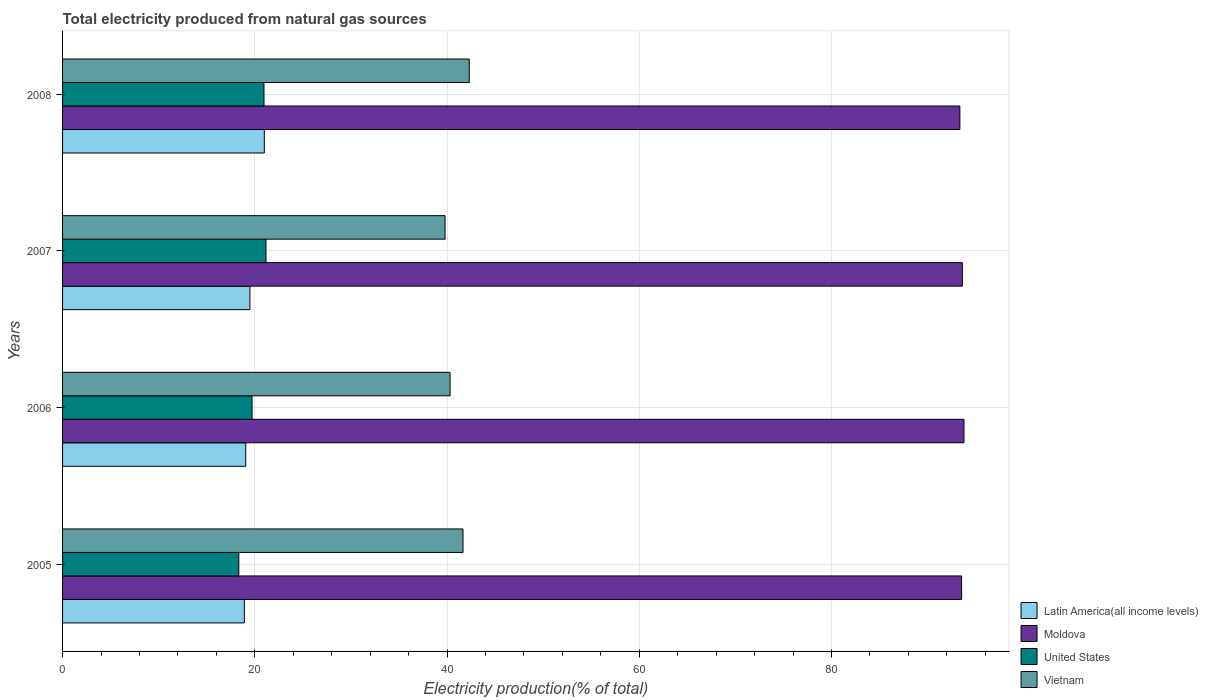How many different coloured bars are there?
Your answer should be compact. 4. Are the number of bars per tick equal to the number of legend labels?
Ensure brevity in your answer.  Yes. Are the number of bars on each tick of the Y-axis equal?
Make the answer very short. Yes. How many bars are there on the 2nd tick from the top?
Ensure brevity in your answer.  4. In how many cases, is the number of bars for a given year not equal to the number of legend labels?
Keep it short and to the point. 0. What is the total electricity produced in Vietnam in 2008?
Provide a short and direct response. 42.31. Across all years, what is the maximum total electricity produced in Moldova?
Provide a short and direct response. 93.78. Across all years, what is the minimum total electricity produced in Vietnam?
Ensure brevity in your answer.  39.8. In which year was the total electricity produced in Vietnam maximum?
Provide a short and direct response. 2008. In which year was the total electricity produced in Vietnam minimum?
Provide a succinct answer. 2007. What is the total total electricity produced in Latin America(all income levels) in the graph?
Make the answer very short. 78.46. What is the difference between the total electricity produced in Latin America(all income levels) in 2005 and that in 2006?
Your response must be concise. -0.14. What is the difference between the total electricity produced in Latin America(all income levels) in 2005 and the total electricity produced in Moldova in 2007?
Your answer should be compact. -74.7. What is the average total electricity produced in Moldova per year?
Offer a terse response. 93.57. In the year 2007, what is the difference between the total electricity produced in Moldova and total electricity produced in United States?
Provide a short and direct response. 72.45. What is the ratio of the total electricity produced in Vietnam in 2005 to that in 2006?
Your response must be concise. 1.03. Is the difference between the total electricity produced in Moldova in 2006 and 2008 greater than the difference between the total electricity produced in United States in 2006 and 2008?
Offer a terse response. Yes. What is the difference between the highest and the second highest total electricity produced in Moldova?
Keep it short and to the point. 0.17. What is the difference between the highest and the lowest total electricity produced in Vietnam?
Keep it short and to the point. 2.52. Is the sum of the total electricity produced in Moldova in 2006 and 2008 greater than the maximum total electricity produced in United States across all years?
Offer a very short reply. Yes. What does the 4th bar from the top in 2006 represents?
Offer a terse response. Latin America(all income levels). What does the 1st bar from the bottom in 2007 represents?
Make the answer very short. Latin America(all income levels). Is it the case that in every year, the sum of the total electricity produced in Vietnam and total electricity produced in Latin America(all income levels) is greater than the total electricity produced in United States?
Offer a very short reply. Yes. How many bars are there?
Your answer should be compact. 16. Are all the bars in the graph horizontal?
Your response must be concise. Yes. How many years are there in the graph?
Keep it short and to the point. 4. Are the values on the major ticks of X-axis written in scientific E-notation?
Make the answer very short. No. Does the graph contain grids?
Your answer should be compact. Yes. How many legend labels are there?
Offer a terse response. 4. How are the legend labels stacked?
Your answer should be very brief. Vertical. What is the title of the graph?
Your answer should be compact. Total electricity produced from natural gas sources. What is the Electricity production(% of total) of Latin America(all income levels) in 2005?
Give a very brief answer. 18.91. What is the Electricity production(% of total) of Moldova in 2005?
Your response must be concise. 93.54. What is the Electricity production(% of total) of United States in 2005?
Ensure brevity in your answer.  18.34. What is the Electricity production(% of total) in Vietnam in 2005?
Give a very brief answer. 41.66. What is the Electricity production(% of total) in Latin America(all income levels) in 2006?
Provide a short and direct response. 19.06. What is the Electricity production(% of total) in Moldova in 2006?
Offer a very short reply. 93.78. What is the Electricity production(% of total) of United States in 2006?
Offer a very short reply. 19.71. What is the Electricity production(% of total) of Vietnam in 2006?
Offer a very short reply. 40.32. What is the Electricity production(% of total) of Latin America(all income levels) in 2007?
Keep it short and to the point. 19.49. What is the Electricity production(% of total) in Moldova in 2007?
Offer a terse response. 93.62. What is the Electricity production(% of total) of United States in 2007?
Provide a short and direct response. 21.17. What is the Electricity production(% of total) in Vietnam in 2007?
Ensure brevity in your answer.  39.8. What is the Electricity production(% of total) of Latin America(all income levels) in 2008?
Your response must be concise. 20.99. What is the Electricity production(% of total) of Moldova in 2008?
Provide a succinct answer. 93.36. What is the Electricity production(% of total) in United States in 2008?
Give a very brief answer. 20.96. What is the Electricity production(% of total) in Vietnam in 2008?
Make the answer very short. 42.31. Across all years, what is the maximum Electricity production(% of total) in Latin America(all income levels)?
Offer a very short reply. 20.99. Across all years, what is the maximum Electricity production(% of total) in Moldova?
Your response must be concise. 93.78. Across all years, what is the maximum Electricity production(% of total) of United States?
Give a very brief answer. 21.17. Across all years, what is the maximum Electricity production(% of total) of Vietnam?
Your response must be concise. 42.31. Across all years, what is the minimum Electricity production(% of total) of Latin America(all income levels)?
Provide a short and direct response. 18.91. Across all years, what is the minimum Electricity production(% of total) in Moldova?
Provide a succinct answer. 93.36. Across all years, what is the minimum Electricity production(% of total) in United States?
Your response must be concise. 18.34. Across all years, what is the minimum Electricity production(% of total) in Vietnam?
Your answer should be very brief. 39.8. What is the total Electricity production(% of total) in Latin America(all income levels) in the graph?
Offer a very short reply. 78.46. What is the total Electricity production(% of total) in Moldova in the graph?
Keep it short and to the point. 374.3. What is the total Electricity production(% of total) of United States in the graph?
Offer a terse response. 80.18. What is the total Electricity production(% of total) of Vietnam in the graph?
Offer a very short reply. 164.09. What is the difference between the Electricity production(% of total) of Latin America(all income levels) in 2005 and that in 2006?
Keep it short and to the point. -0.14. What is the difference between the Electricity production(% of total) in Moldova in 2005 and that in 2006?
Keep it short and to the point. -0.24. What is the difference between the Electricity production(% of total) of United States in 2005 and that in 2006?
Offer a very short reply. -1.38. What is the difference between the Electricity production(% of total) in Vietnam in 2005 and that in 2006?
Your answer should be very brief. 1.34. What is the difference between the Electricity production(% of total) in Latin America(all income levels) in 2005 and that in 2007?
Keep it short and to the point. -0.58. What is the difference between the Electricity production(% of total) in Moldova in 2005 and that in 2007?
Your answer should be compact. -0.08. What is the difference between the Electricity production(% of total) in United States in 2005 and that in 2007?
Your response must be concise. -2.83. What is the difference between the Electricity production(% of total) of Vietnam in 2005 and that in 2007?
Offer a very short reply. 1.87. What is the difference between the Electricity production(% of total) in Latin America(all income levels) in 2005 and that in 2008?
Offer a terse response. -2.08. What is the difference between the Electricity production(% of total) in Moldova in 2005 and that in 2008?
Your answer should be very brief. 0.18. What is the difference between the Electricity production(% of total) in United States in 2005 and that in 2008?
Provide a succinct answer. -2.62. What is the difference between the Electricity production(% of total) in Vietnam in 2005 and that in 2008?
Your answer should be compact. -0.65. What is the difference between the Electricity production(% of total) in Latin America(all income levels) in 2006 and that in 2007?
Offer a very short reply. -0.43. What is the difference between the Electricity production(% of total) of Moldova in 2006 and that in 2007?
Offer a very short reply. 0.17. What is the difference between the Electricity production(% of total) in United States in 2006 and that in 2007?
Offer a terse response. -1.45. What is the difference between the Electricity production(% of total) in Vietnam in 2006 and that in 2007?
Offer a very short reply. 0.52. What is the difference between the Electricity production(% of total) in Latin America(all income levels) in 2006 and that in 2008?
Provide a succinct answer. -1.93. What is the difference between the Electricity production(% of total) of Moldova in 2006 and that in 2008?
Keep it short and to the point. 0.43. What is the difference between the Electricity production(% of total) in United States in 2006 and that in 2008?
Give a very brief answer. -1.24. What is the difference between the Electricity production(% of total) in Vietnam in 2006 and that in 2008?
Make the answer very short. -2. What is the difference between the Electricity production(% of total) in Latin America(all income levels) in 2007 and that in 2008?
Your answer should be very brief. -1.5. What is the difference between the Electricity production(% of total) of Moldova in 2007 and that in 2008?
Your answer should be very brief. 0.26. What is the difference between the Electricity production(% of total) of United States in 2007 and that in 2008?
Your answer should be very brief. 0.21. What is the difference between the Electricity production(% of total) of Vietnam in 2007 and that in 2008?
Keep it short and to the point. -2.52. What is the difference between the Electricity production(% of total) in Latin America(all income levels) in 2005 and the Electricity production(% of total) in Moldova in 2006?
Your answer should be very brief. -74.87. What is the difference between the Electricity production(% of total) of Latin America(all income levels) in 2005 and the Electricity production(% of total) of United States in 2006?
Offer a terse response. -0.8. What is the difference between the Electricity production(% of total) of Latin America(all income levels) in 2005 and the Electricity production(% of total) of Vietnam in 2006?
Your response must be concise. -21.4. What is the difference between the Electricity production(% of total) of Moldova in 2005 and the Electricity production(% of total) of United States in 2006?
Provide a succinct answer. 73.83. What is the difference between the Electricity production(% of total) in Moldova in 2005 and the Electricity production(% of total) in Vietnam in 2006?
Your answer should be very brief. 53.22. What is the difference between the Electricity production(% of total) in United States in 2005 and the Electricity production(% of total) in Vietnam in 2006?
Keep it short and to the point. -21.98. What is the difference between the Electricity production(% of total) in Latin America(all income levels) in 2005 and the Electricity production(% of total) in Moldova in 2007?
Make the answer very short. -74.7. What is the difference between the Electricity production(% of total) of Latin America(all income levels) in 2005 and the Electricity production(% of total) of United States in 2007?
Offer a very short reply. -2.25. What is the difference between the Electricity production(% of total) of Latin America(all income levels) in 2005 and the Electricity production(% of total) of Vietnam in 2007?
Make the answer very short. -20.88. What is the difference between the Electricity production(% of total) in Moldova in 2005 and the Electricity production(% of total) in United States in 2007?
Give a very brief answer. 72.37. What is the difference between the Electricity production(% of total) of Moldova in 2005 and the Electricity production(% of total) of Vietnam in 2007?
Make the answer very short. 53.74. What is the difference between the Electricity production(% of total) in United States in 2005 and the Electricity production(% of total) in Vietnam in 2007?
Your answer should be compact. -21.46. What is the difference between the Electricity production(% of total) in Latin America(all income levels) in 2005 and the Electricity production(% of total) in Moldova in 2008?
Give a very brief answer. -74.44. What is the difference between the Electricity production(% of total) in Latin America(all income levels) in 2005 and the Electricity production(% of total) in United States in 2008?
Provide a succinct answer. -2.04. What is the difference between the Electricity production(% of total) of Latin America(all income levels) in 2005 and the Electricity production(% of total) of Vietnam in 2008?
Your answer should be compact. -23.4. What is the difference between the Electricity production(% of total) in Moldova in 2005 and the Electricity production(% of total) in United States in 2008?
Your answer should be compact. 72.58. What is the difference between the Electricity production(% of total) of Moldova in 2005 and the Electricity production(% of total) of Vietnam in 2008?
Your answer should be very brief. 51.23. What is the difference between the Electricity production(% of total) in United States in 2005 and the Electricity production(% of total) in Vietnam in 2008?
Provide a succinct answer. -23.97. What is the difference between the Electricity production(% of total) in Latin America(all income levels) in 2006 and the Electricity production(% of total) in Moldova in 2007?
Your response must be concise. -74.56. What is the difference between the Electricity production(% of total) in Latin America(all income levels) in 2006 and the Electricity production(% of total) in United States in 2007?
Make the answer very short. -2.11. What is the difference between the Electricity production(% of total) in Latin America(all income levels) in 2006 and the Electricity production(% of total) in Vietnam in 2007?
Provide a short and direct response. -20.74. What is the difference between the Electricity production(% of total) in Moldova in 2006 and the Electricity production(% of total) in United States in 2007?
Offer a very short reply. 72.62. What is the difference between the Electricity production(% of total) in Moldova in 2006 and the Electricity production(% of total) in Vietnam in 2007?
Give a very brief answer. 53.99. What is the difference between the Electricity production(% of total) of United States in 2006 and the Electricity production(% of total) of Vietnam in 2007?
Ensure brevity in your answer.  -20.08. What is the difference between the Electricity production(% of total) of Latin America(all income levels) in 2006 and the Electricity production(% of total) of Moldova in 2008?
Keep it short and to the point. -74.3. What is the difference between the Electricity production(% of total) of Latin America(all income levels) in 2006 and the Electricity production(% of total) of United States in 2008?
Ensure brevity in your answer.  -1.9. What is the difference between the Electricity production(% of total) in Latin America(all income levels) in 2006 and the Electricity production(% of total) in Vietnam in 2008?
Give a very brief answer. -23.25. What is the difference between the Electricity production(% of total) of Moldova in 2006 and the Electricity production(% of total) of United States in 2008?
Your response must be concise. 72.83. What is the difference between the Electricity production(% of total) in Moldova in 2006 and the Electricity production(% of total) in Vietnam in 2008?
Provide a succinct answer. 51.47. What is the difference between the Electricity production(% of total) of United States in 2006 and the Electricity production(% of total) of Vietnam in 2008?
Make the answer very short. -22.6. What is the difference between the Electricity production(% of total) in Latin America(all income levels) in 2007 and the Electricity production(% of total) in Moldova in 2008?
Provide a succinct answer. -73.86. What is the difference between the Electricity production(% of total) of Latin America(all income levels) in 2007 and the Electricity production(% of total) of United States in 2008?
Give a very brief answer. -1.46. What is the difference between the Electricity production(% of total) of Latin America(all income levels) in 2007 and the Electricity production(% of total) of Vietnam in 2008?
Give a very brief answer. -22.82. What is the difference between the Electricity production(% of total) in Moldova in 2007 and the Electricity production(% of total) in United States in 2008?
Make the answer very short. 72.66. What is the difference between the Electricity production(% of total) of Moldova in 2007 and the Electricity production(% of total) of Vietnam in 2008?
Your answer should be very brief. 51.3. What is the difference between the Electricity production(% of total) in United States in 2007 and the Electricity production(% of total) in Vietnam in 2008?
Offer a terse response. -21.15. What is the average Electricity production(% of total) in Latin America(all income levels) per year?
Your answer should be very brief. 19.61. What is the average Electricity production(% of total) of Moldova per year?
Keep it short and to the point. 93.57. What is the average Electricity production(% of total) in United States per year?
Keep it short and to the point. 20.04. What is the average Electricity production(% of total) of Vietnam per year?
Ensure brevity in your answer.  41.02. In the year 2005, what is the difference between the Electricity production(% of total) in Latin America(all income levels) and Electricity production(% of total) in Moldova?
Offer a terse response. -74.62. In the year 2005, what is the difference between the Electricity production(% of total) in Latin America(all income levels) and Electricity production(% of total) in United States?
Ensure brevity in your answer.  0.58. In the year 2005, what is the difference between the Electricity production(% of total) in Latin America(all income levels) and Electricity production(% of total) in Vietnam?
Your response must be concise. -22.75. In the year 2005, what is the difference between the Electricity production(% of total) of Moldova and Electricity production(% of total) of United States?
Provide a succinct answer. 75.2. In the year 2005, what is the difference between the Electricity production(% of total) in Moldova and Electricity production(% of total) in Vietnam?
Your answer should be very brief. 51.88. In the year 2005, what is the difference between the Electricity production(% of total) in United States and Electricity production(% of total) in Vietnam?
Offer a terse response. -23.32. In the year 2006, what is the difference between the Electricity production(% of total) of Latin America(all income levels) and Electricity production(% of total) of Moldova?
Keep it short and to the point. -74.72. In the year 2006, what is the difference between the Electricity production(% of total) of Latin America(all income levels) and Electricity production(% of total) of United States?
Keep it short and to the point. -0.65. In the year 2006, what is the difference between the Electricity production(% of total) in Latin America(all income levels) and Electricity production(% of total) in Vietnam?
Give a very brief answer. -21.26. In the year 2006, what is the difference between the Electricity production(% of total) of Moldova and Electricity production(% of total) of United States?
Your response must be concise. 74.07. In the year 2006, what is the difference between the Electricity production(% of total) in Moldova and Electricity production(% of total) in Vietnam?
Your response must be concise. 53.47. In the year 2006, what is the difference between the Electricity production(% of total) in United States and Electricity production(% of total) in Vietnam?
Keep it short and to the point. -20.6. In the year 2007, what is the difference between the Electricity production(% of total) in Latin America(all income levels) and Electricity production(% of total) in Moldova?
Ensure brevity in your answer.  -74.12. In the year 2007, what is the difference between the Electricity production(% of total) in Latin America(all income levels) and Electricity production(% of total) in United States?
Your answer should be compact. -1.67. In the year 2007, what is the difference between the Electricity production(% of total) of Latin America(all income levels) and Electricity production(% of total) of Vietnam?
Offer a terse response. -20.3. In the year 2007, what is the difference between the Electricity production(% of total) of Moldova and Electricity production(% of total) of United States?
Offer a terse response. 72.45. In the year 2007, what is the difference between the Electricity production(% of total) of Moldova and Electricity production(% of total) of Vietnam?
Ensure brevity in your answer.  53.82. In the year 2007, what is the difference between the Electricity production(% of total) of United States and Electricity production(% of total) of Vietnam?
Make the answer very short. -18.63. In the year 2008, what is the difference between the Electricity production(% of total) of Latin America(all income levels) and Electricity production(% of total) of Moldova?
Offer a terse response. -72.37. In the year 2008, what is the difference between the Electricity production(% of total) in Latin America(all income levels) and Electricity production(% of total) in United States?
Ensure brevity in your answer.  0.03. In the year 2008, what is the difference between the Electricity production(% of total) in Latin America(all income levels) and Electricity production(% of total) in Vietnam?
Provide a short and direct response. -21.32. In the year 2008, what is the difference between the Electricity production(% of total) in Moldova and Electricity production(% of total) in United States?
Your response must be concise. 72.4. In the year 2008, what is the difference between the Electricity production(% of total) in Moldova and Electricity production(% of total) in Vietnam?
Ensure brevity in your answer.  51.04. In the year 2008, what is the difference between the Electricity production(% of total) in United States and Electricity production(% of total) in Vietnam?
Your response must be concise. -21.36. What is the ratio of the Electricity production(% of total) of United States in 2005 to that in 2006?
Offer a very short reply. 0.93. What is the ratio of the Electricity production(% of total) of Vietnam in 2005 to that in 2006?
Your answer should be very brief. 1.03. What is the ratio of the Electricity production(% of total) of Latin America(all income levels) in 2005 to that in 2007?
Ensure brevity in your answer.  0.97. What is the ratio of the Electricity production(% of total) in Moldova in 2005 to that in 2007?
Make the answer very short. 1. What is the ratio of the Electricity production(% of total) in United States in 2005 to that in 2007?
Offer a very short reply. 0.87. What is the ratio of the Electricity production(% of total) in Vietnam in 2005 to that in 2007?
Provide a short and direct response. 1.05. What is the ratio of the Electricity production(% of total) of Latin America(all income levels) in 2005 to that in 2008?
Offer a very short reply. 0.9. What is the ratio of the Electricity production(% of total) of Moldova in 2005 to that in 2008?
Ensure brevity in your answer.  1. What is the ratio of the Electricity production(% of total) of Vietnam in 2005 to that in 2008?
Offer a very short reply. 0.98. What is the ratio of the Electricity production(% of total) of Latin America(all income levels) in 2006 to that in 2007?
Make the answer very short. 0.98. What is the ratio of the Electricity production(% of total) of United States in 2006 to that in 2007?
Your response must be concise. 0.93. What is the ratio of the Electricity production(% of total) in Vietnam in 2006 to that in 2007?
Keep it short and to the point. 1.01. What is the ratio of the Electricity production(% of total) of Latin America(all income levels) in 2006 to that in 2008?
Provide a succinct answer. 0.91. What is the ratio of the Electricity production(% of total) in Moldova in 2006 to that in 2008?
Offer a terse response. 1. What is the ratio of the Electricity production(% of total) in United States in 2006 to that in 2008?
Provide a succinct answer. 0.94. What is the ratio of the Electricity production(% of total) in Vietnam in 2006 to that in 2008?
Make the answer very short. 0.95. What is the ratio of the Electricity production(% of total) of Latin America(all income levels) in 2007 to that in 2008?
Your response must be concise. 0.93. What is the ratio of the Electricity production(% of total) of Moldova in 2007 to that in 2008?
Offer a very short reply. 1. What is the ratio of the Electricity production(% of total) of United States in 2007 to that in 2008?
Offer a terse response. 1.01. What is the ratio of the Electricity production(% of total) in Vietnam in 2007 to that in 2008?
Provide a succinct answer. 0.94. What is the difference between the highest and the second highest Electricity production(% of total) in Latin America(all income levels)?
Offer a terse response. 1.5. What is the difference between the highest and the second highest Electricity production(% of total) in Moldova?
Make the answer very short. 0.17. What is the difference between the highest and the second highest Electricity production(% of total) of United States?
Provide a succinct answer. 0.21. What is the difference between the highest and the second highest Electricity production(% of total) in Vietnam?
Your answer should be compact. 0.65. What is the difference between the highest and the lowest Electricity production(% of total) of Latin America(all income levels)?
Keep it short and to the point. 2.08. What is the difference between the highest and the lowest Electricity production(% of total) in Moldova?
Provide a short and direct response. 0.43. What is the difference between the highest and the lowest Electricity production(% of total) in United States?
Offer a very short reply. 2.83. What is the difference between the highest and the lowest Electricity production(% of total) of Vietnam?
Make the answer very short. 2.52. 